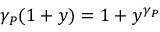Convert formula to latex. <formula><loc_0><loc_0><loc_500><loc_500>\gamma _ { P } ( 1 + y ) = 1 + y ^ { \gamma _ { P } }</formula> 